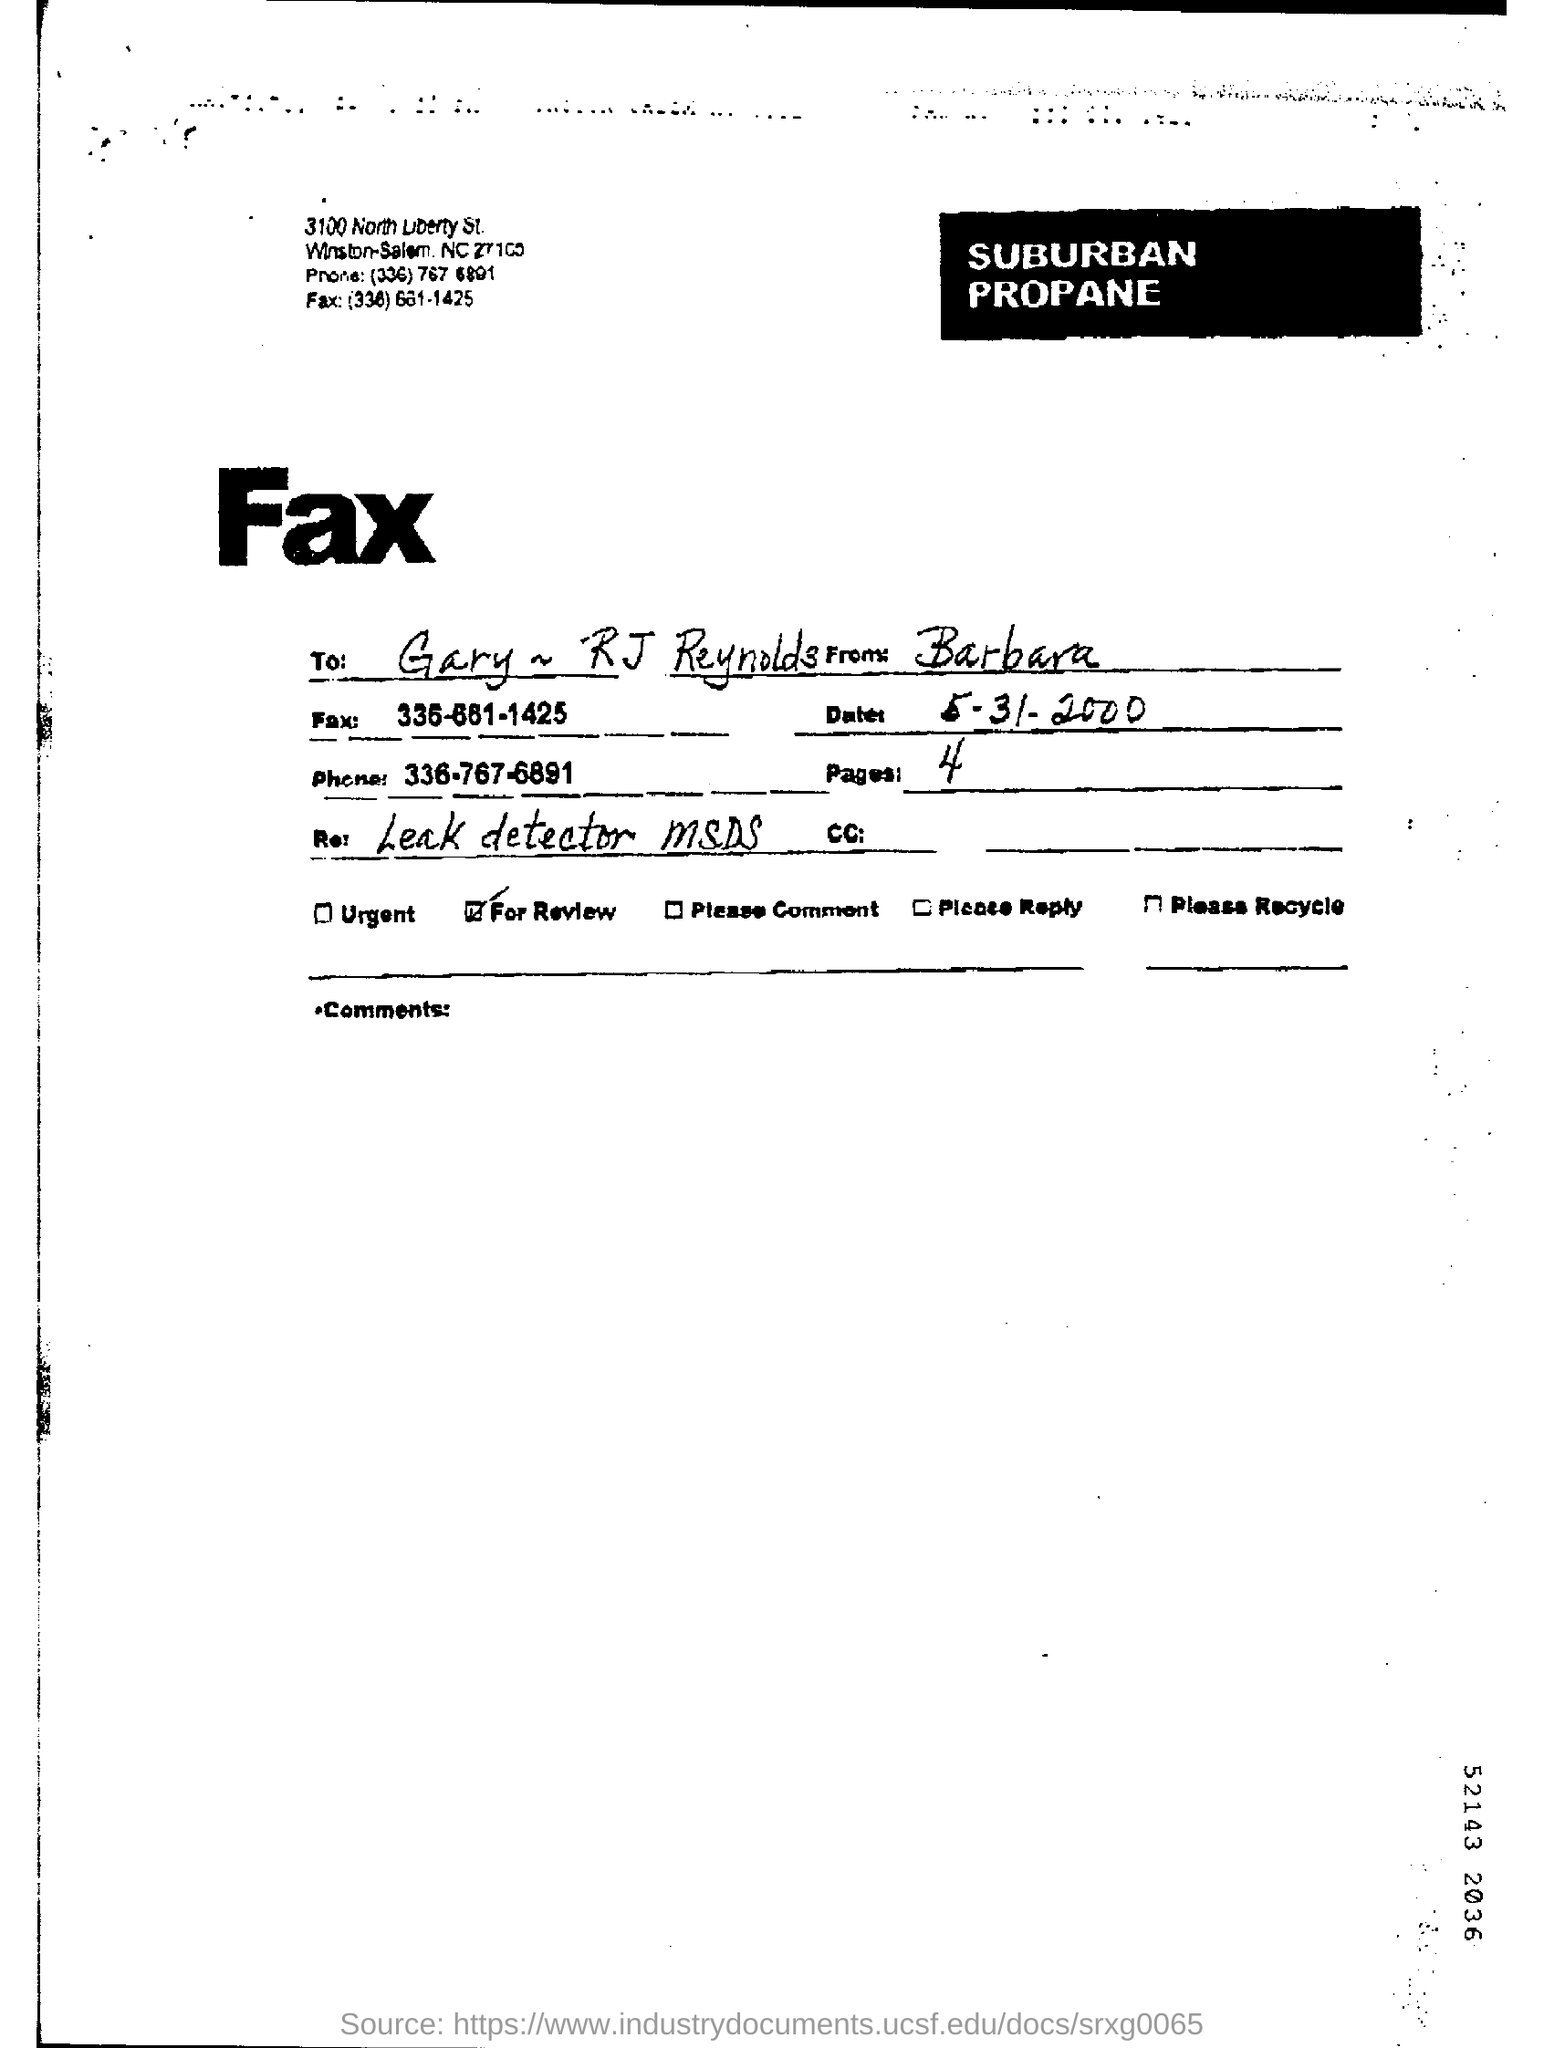List a handful of essential elements in this visual. The date mentioned in the fax is May 31st, 2000. There are 4 pages in the fax. The phone number mentioned in the fax is 336-767-6891. 